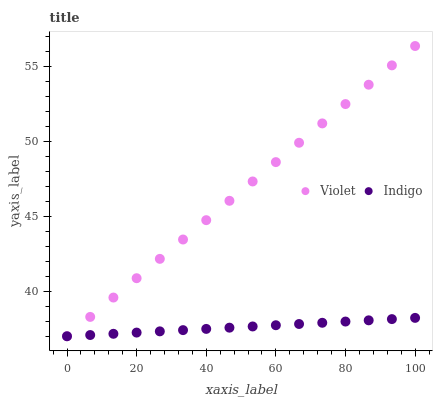Does Indigo have the minimum area under the curve?
Answer yes or no. Yes. Does Violet have the maximum area under the curve?
Answer yes or no. Yes. Does Violet have the minimum area under the curve?
Answer yes or no. No. Is Indigo the smoothest?
Answer yes or no. Yes. Is Violet the roughest?
Answer yes or no. Yes. Is Violet the smoothest?
Answer yes or no. No. Does Indigo have the lowest value?
Answer yes or no. Yes. Does Violet have the highest value?
Answer yes or no. Yes. Does Violet intersect Indigo?
Answer yes or no. Yes. Is Violet less than Indigo?
Answer yes or no. No. Is Violet greater than Indigo?
Answer yes or no. No. 